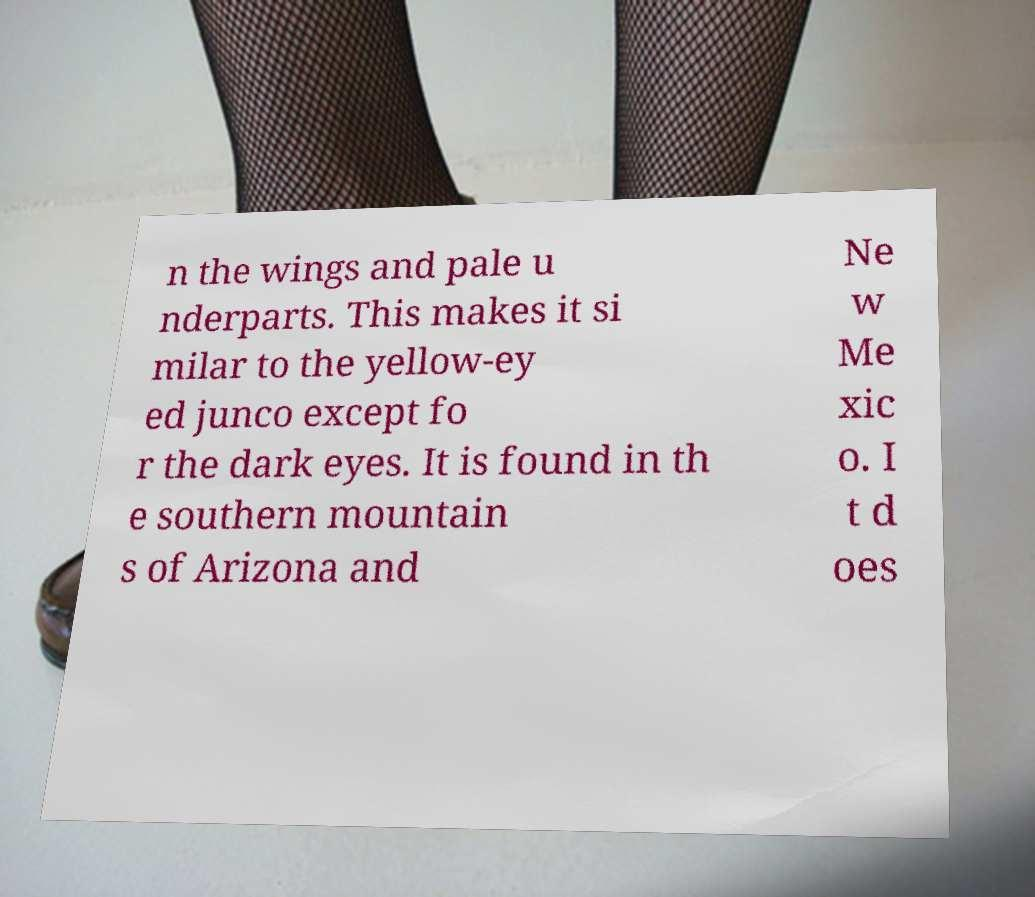What messages or text are displayed in this image? I need them in a readable, typed format. n the wings and pale u nderparts. This makes it si milar to the yellow-ey ed junco except fo r the dark eyes. It is found in th e southern mountain s of Arizona and Ne w Me xic o. I t d oes 